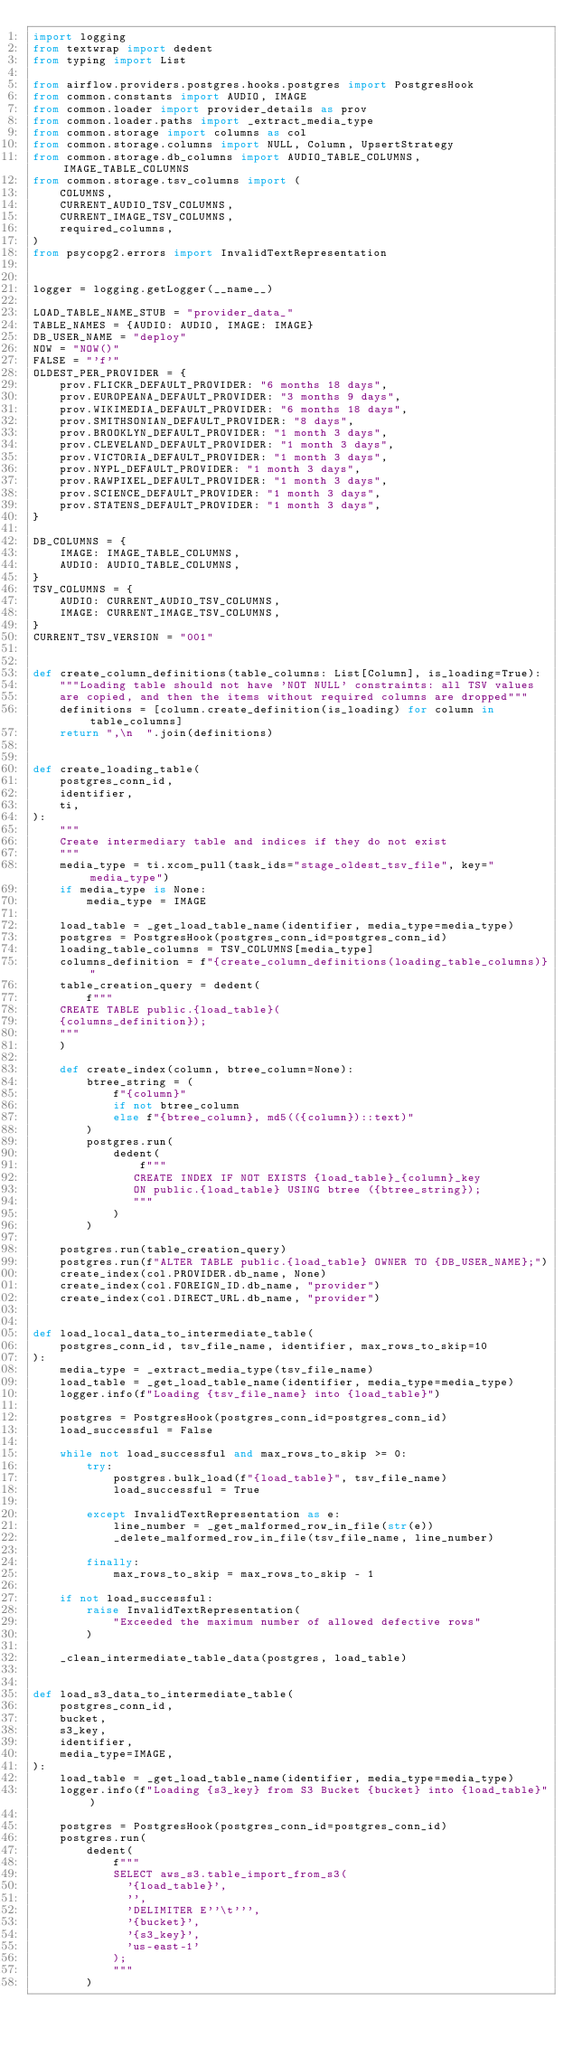<code> <loc_0><loc_0><loc_500><loc_500><_Python_>import logging
from textwrap import dedent
from typing import List

from airflow.providers.postgres.hooks.postgres import PostgresHook
from common.constants import AUDIO, IMAGE
from common.loader import provider_details as prov
from common.loader.paths import _extract_media_type
from common.storage import columns as col
from common.storage.columns import NULL, Column, UpsertStrategy
from common.storage.db_columns import AUDIO_TABLE_COLUMNS, IMAGE_TABLE_COLUMNS
from common.storage.tsv_columns import (
    COLUMNS,
    CURRENT_AUDIO_TSV_COLUMNS,
    CURRENT_IMAGE_TSV_COLUMNS,
    required_columns,
)
from psycopg2.errors import InvalidTextRepresentation


logger = logging.getLogger(__name__)

LOAD_TABLE_NAME_STUB = "provider_data_"
TABLE_NAMES = {AUDIO: AUDIO, IMAGE: IMAGE}
DB_USER_NAME = "deploy"
NOW = "NOW()"
FALSE = "'f'"
OLDEST_PER_PROVIDER = {
    prov.FLICKR_DEFAULT_PROVIDER: "6 months 18 days",
    prov.EUROPEANA_DEFAULT_PROVIDER: "3 months 9 days",
    prov.WIKIMEDIA_DEFAULT_PROVIDER: "6 months 18 days",
    prov.SMITHSONIAN_DEFAULT_PROVIDER: "8 days",
    prov.BROOKLYN_DEFAULT_PROVIDER: "1 month 3 days",
    prov.CLEVELAND_DEFAULT_PROVIDER: "1 month 3 days",
    prov.VICTORIA_DEFAULT_PROVIDER: "1 month 3 days",
    prov.NYPL_DEFAULT_PROVIDER: "1 month 3 days",
    prov.RAWPIXEL_DEFAULT_PROVIDER: "1 month 3 days",
    prov.SCIENCE_DEFAULT_PROVIDER: "1 month 3 days",
    prov.STATENS_DEFAULT_PROVIDER: "1 month 3 days",
}

DB_COLUMNS = {
    IMAGE: IMAGE_TABLE_COLUMNS,
    AUDIO: AUDIO_TABLE_COLUMNS,
}
TSV_COLUMNS = {
    AUDIO: CURRENT_AUDIO_TSV_COLUMNS,
    IMAGE: CURRENT_IMAGE_TSV_COLUMNS,
}
CURRENT_TSV_VERSION = "001"


def create_column_definitions(table_columns: List[Column], is_loading=True):
    """Loading table should not have 'NOT NULL' constraints: all TSV values
    are copied, and then the items without required columns are dropped"""
    definitions = [column.create_definition(is_loading) for column in table_columns]
    return ",\n  ".join(definitions)


def create_loading_table(
    postgres_conn_id,
    identifier,
    ti,
):
    """
    Create intermediary table and indices if they do not exist
    """
    media_type = ti.xcom_pull(task_ids="stage_oldest_tsv_file", key="media_type")
    if media_type is None:
        media_type = IMAGE

    load_table = _get_load_table_name(identifier, media_type=media_type)
    postgres = PostgresHook(postgres_conn_id=postgres_conn_id)
    loading_table_columns = TSV_COLUMNS[media_type]
    columns_definition = f"{create_column_definitions(loading_table_columns)}"
    table_creation_query = dedent(
        f"""
    CREATE TABLE public.{load_table}(
    {columns_definition});
    """
    )

    def create_index(column, btree_column=None):
        btree_string = (
            f"{column}"
            if not btree_column
            else f"{btree_column}, md5(({column})::text)"
        )
        postgres.run(
            dedent(
                f"""
               CREATE INDEX IF NOT EXISTS {load_table}_{column}_key
               ON public.{load_table} USING btree ({btree_string});
               """
            )
        )

    postgres.run(table_creation_query)
    postgres.run(f"ALTER TABLE public.{load_table} OWNER TO {DB_USER_NAME};")
    create_index(col.PROVIDER.db_name, None)
    create_index(col.FOREIGN_ID.db_name, "provider")
    create_index(col.DIRECT_URL.db_name, "provider")


def load_local_data_to_intermediate_table(
    postgres_conn_id, tsv_file_name, identifier, max_rows_to_skip=10
):
    media_type = _extract_media_type(tsv_file_name)
    load_table = _get_load_table_name(identifier, media_type=media_type)
    logger.info(f"Loading {tsv_file_name} into {load_table}")

    postgres = PostgresHook(postgres_conn_id=postgres_conn_id)
    load_successful = False

    while not load_successful and max_rows_to_skip >= 0:
        try:
            postgres.bulk_load(f"{load_table}", tsv_file_name)
            load_successful = True

        except InvalidTextRepresentation as e:
            line_number = _get_malformed_row_in_file(str(e))
            _delete_malformed_row_in_file(tsv_file_name, line_number)

        finally:
            max_rows_to_skip = max_rows_to_skip - 1

    if not load_successful:
        raise InvalidTextRepresentation(
            "Exceeded the maximum number of allowed defective rows"
        )

    _clean_intermediate_table_data(postgres, load_table)


def load_s3_data_to_intermediate_table(
    postgres_conn_id,
    bucket,
    s3_key,
    identifier,
    media_type=IMAGE,
):
    load_table = _get_load_table_name(identifier, media_type=media_type)
    logger.info(f"Loading {s3_key} from S3 Bucket {bucket} into {load_table}")

    postgres = PostgresHook(postgres_conn_id=postgres_conn_id)
    postgres.run(
        dedent(
            f"""
            SELECT aws_s3.table_import_from_s3(
              '{load_table}',
              '',
              'DELIMITER E''\t''',
              '{bucket}',
              '{s3_key}',
              'us-east-1'
            );
            """
        )</code> 